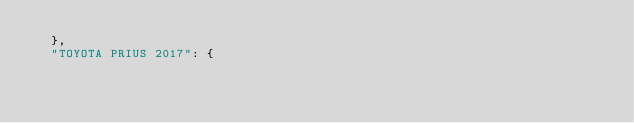Convert code to text. <code><loc_0><loc_0><loc_500><loc_500><_Python_>  },
  "TOYOTA PRIUS 2017": {</code> 